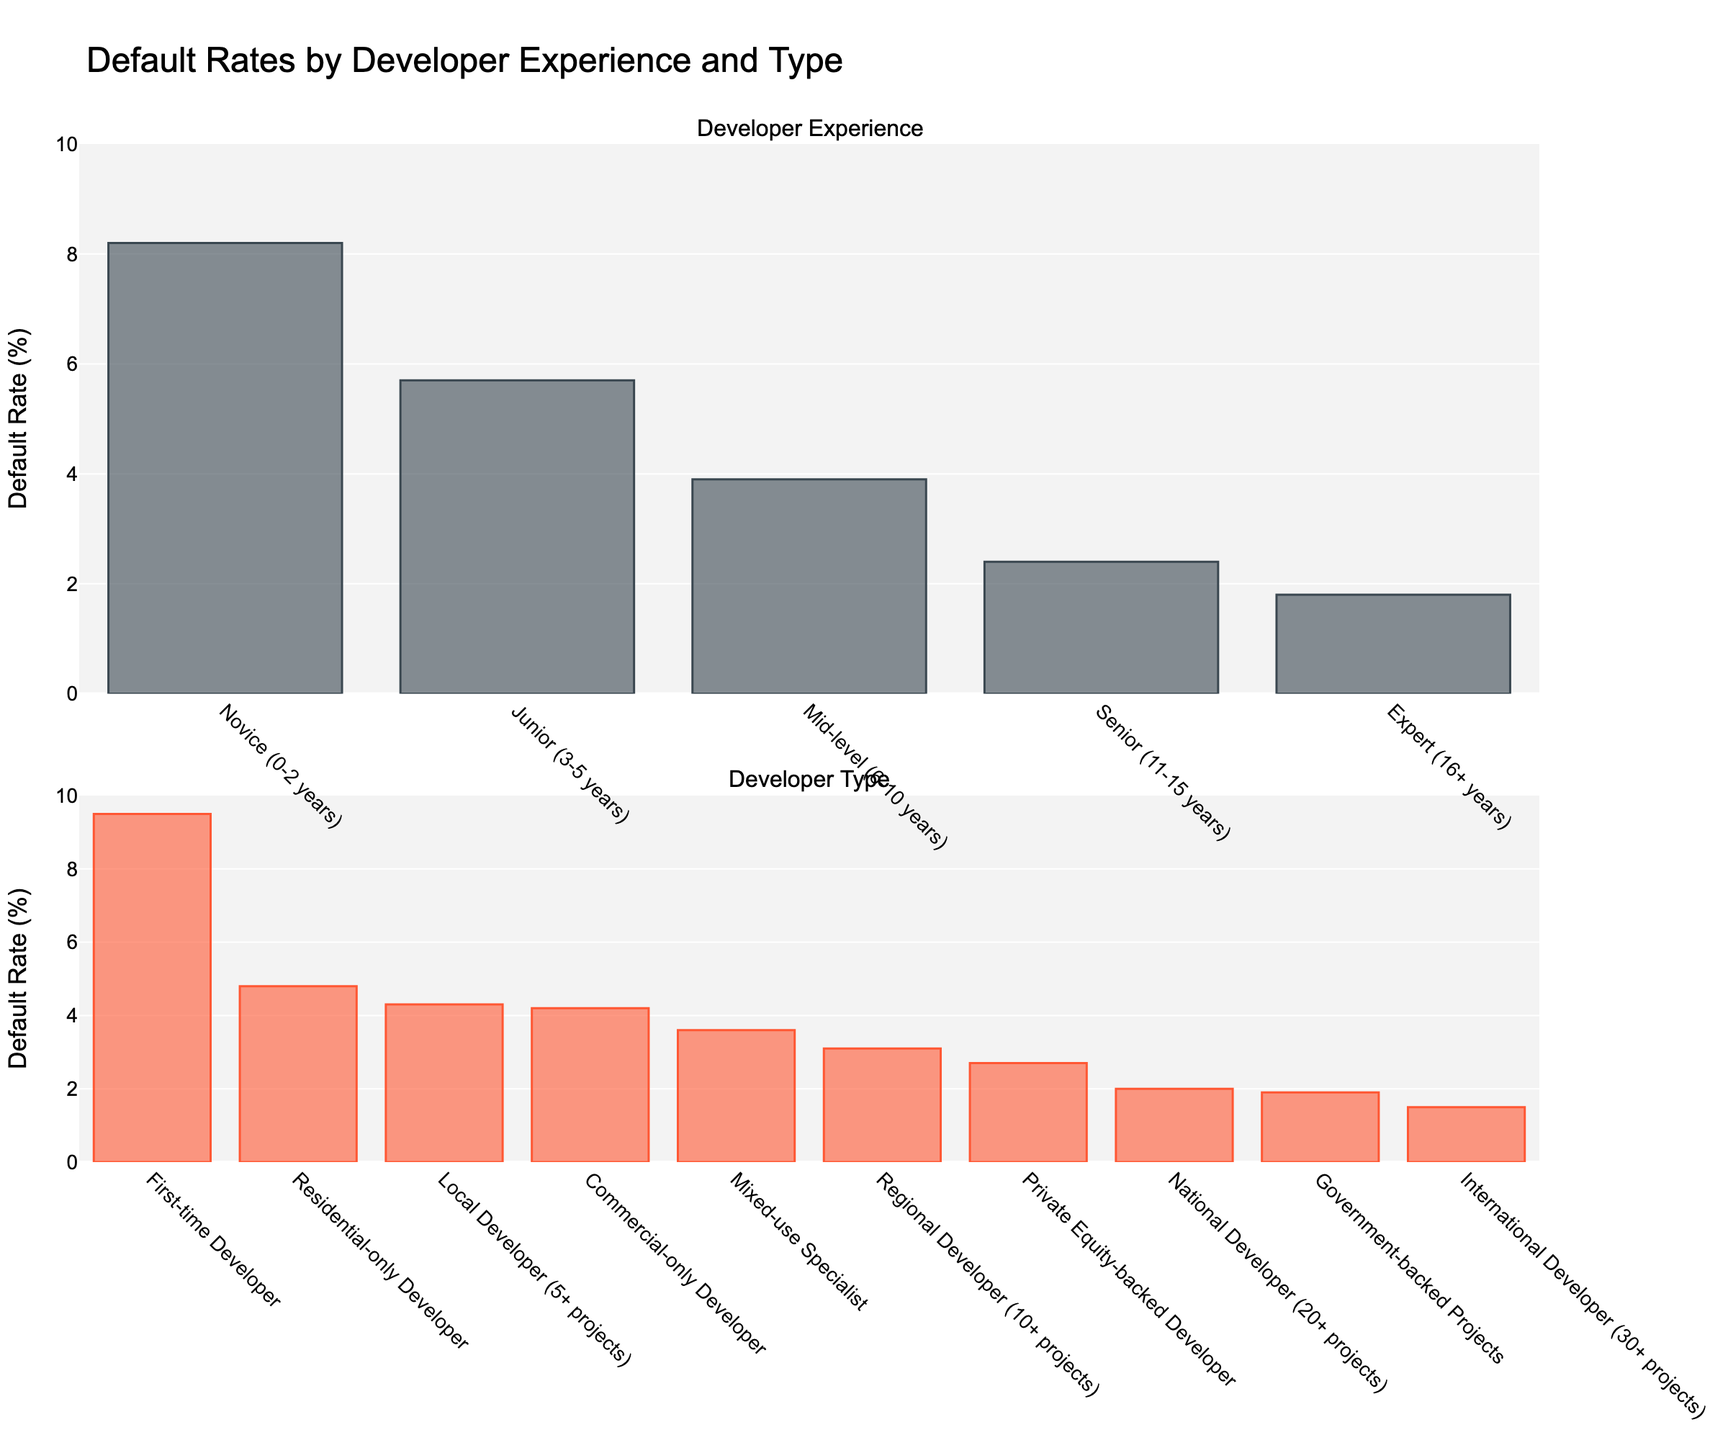What is the default rate for Novice developers? The Novice developers bar in the chart shows a height corresponding to 8.2%.
Answer: 8.2% Which developer experience level has the lowest default rate? By examining the heights of the bars, the Expert (16+ years) category has the shortest bar, indicating the lowest default rate of 1.8%.
Answer: Expert (16+ years) Compare the default rates for Junior and Mid-level developers. Which one is higher, and by how much? The default rate for Junior developers is 5.7% and for Mid-level developers it's 3.9%. The difference is 5.7% - 3.9% = 1.8%.
Answer: Junior, by 1.8% What is the combined default rate for Residential-only and Commercial-only developers? The default rates for Residential-only and Commercial-only developers are 4.8% and 4.2%, respectively. Adding them together: 4.8% + 4.2% = 9.0%.
Answer: 9.0% Which type of developer has a higher default rate: Local Developer (5+ projects) or Private Equity-backed Developer? The default rate for Local Developer is 4.3%, while for Private Equity-backed Developer it is 2.7%. Therefore, Local Developer has a higher default rate.
Answer: Local Developer What is the difference in default rates between National Developers and Government-backed Projects? The default rate for National Developers is 2.0%, and for Government-backed Projects, it's 1.9%. The difference is 2.0% - 1.9% = 0.1%.
Answer: 0.1% How much lower is the default rate for International Developers compared to First-time Developers? The default rate for International Developers is 1.5% and for First-time Developers it is 9.5%. The difference is 9.5% - 1.5% = 8.0%.
Answer: 8.0% Which developer experience level or type has a higher default rate: Senior (11-15 years) or Mixed-use Specialist? The default rate for Senior (11-15 years) is 2.4%, while for Mixed-use Specialist it is 3.6%. Thus, Mixed-use Specialist has a higher default rate.
Answer: Mixed-use Specialist What is the average default rate of the developers categorized by their experience levels (excluding types)? The default rates for Novice, Junior, Mid-level, Senior, and Expert developers are 8.2%, 5.7%, 3.9%, 2.4%, and 1.8%, respectively. The average default rate is (8.2% + 5.7% + 3.9% + 2.4% + 1.8%) / 5 = 4.4%.
Answer: 4.4% What is the visual difference between the bars representing Expert developers and International Developers? The bars are visually distinguished by colors; the Expert developers' bar is shaded in gray/black, while International Developers' bar is shaded in orange/red. The height also shows that International Developers have a slightly lower default rate (1.5%) compared to Expert developers (1.8%).
Answer: Different colors and heights, International is lower 